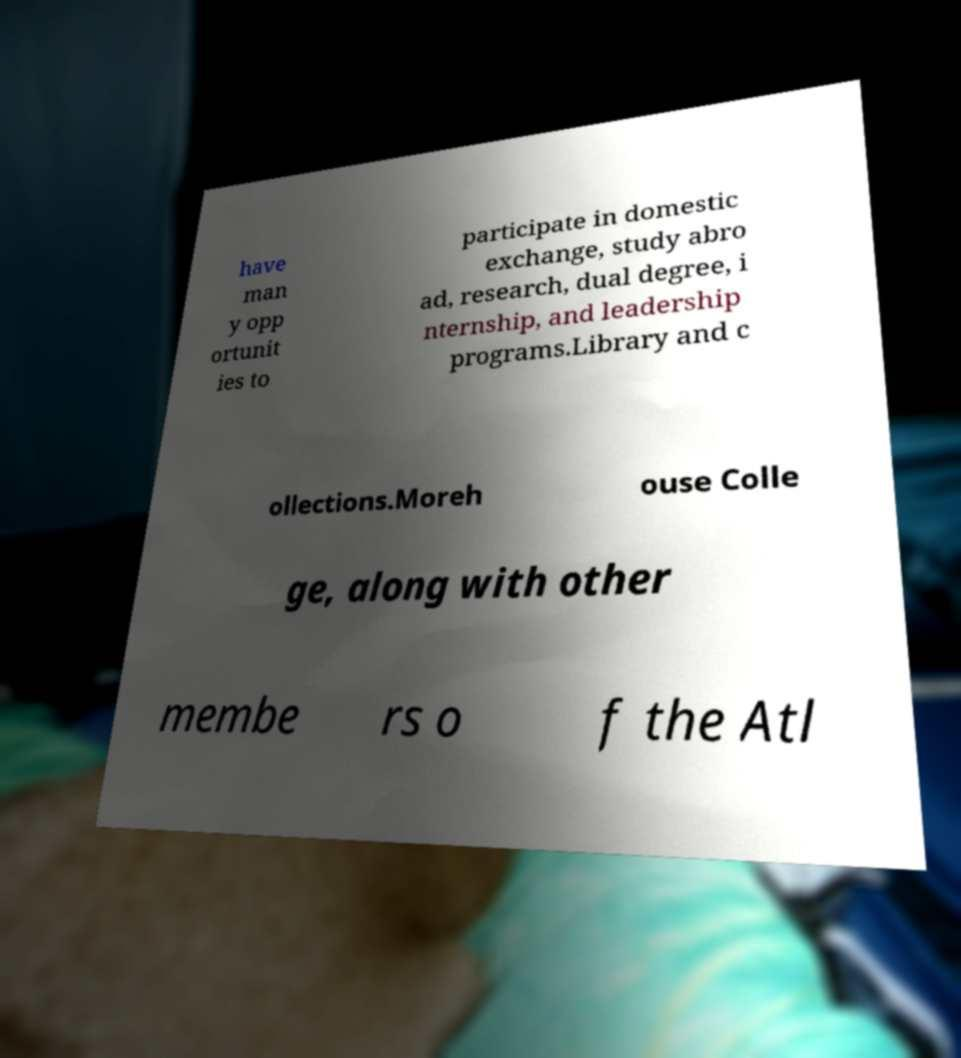Please identify and transcribe the text found in this image. have man y opp ortunit ies to participate in domestic exchange, study abro ad, research, dual degree, i nternship, and leadership programs.Library and c ollections.Moreh ouse Colle ge, along with other membe rs o f the Atl 